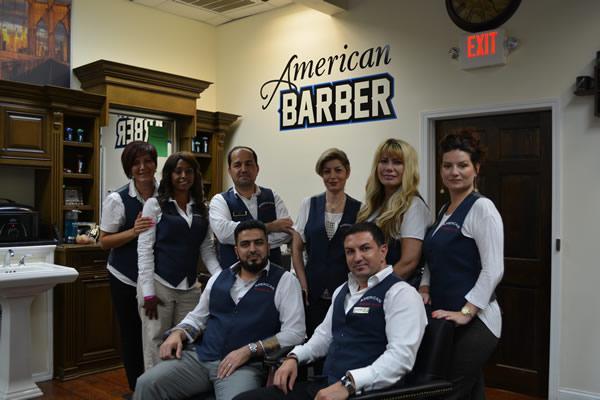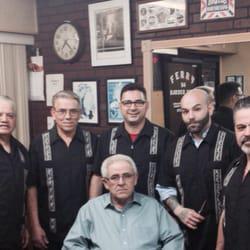The first image is the image on the left, the second image is the image on the right. For the images shown, is this caption "There are at least three people in red capes getting there hair cut." true? Answer yes or no. No. The first image is the image on the left, the second image is the image on the right. Evaluate the accuracy of this statement regarding the images: "Someone is at the desk in the left image.". Is it true? Answer yes or no. No. 